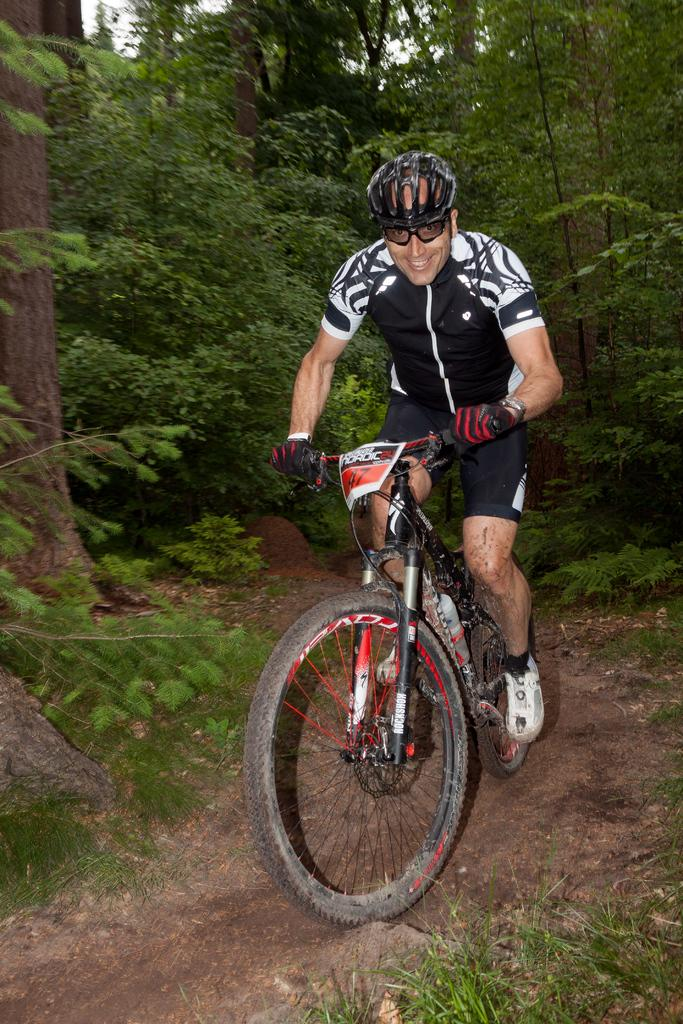Who is the person in the image? There is a man in the image. What protective gear is the man wearing? The man is wearing a helmet, goggles, gloves, and shoes. What activity is the man engaged in? The man is riding a bicycle. What is the position of the bicycle in the image? The bicycle is on the ground. What can be seen in the background of the image? There are trees in the background of the image. What type of prose is the man reading while riding the bicycle in the image? There is no indication in the image that the man is reading any prose; he is wearing goggles and focused on riding the bicycle. 